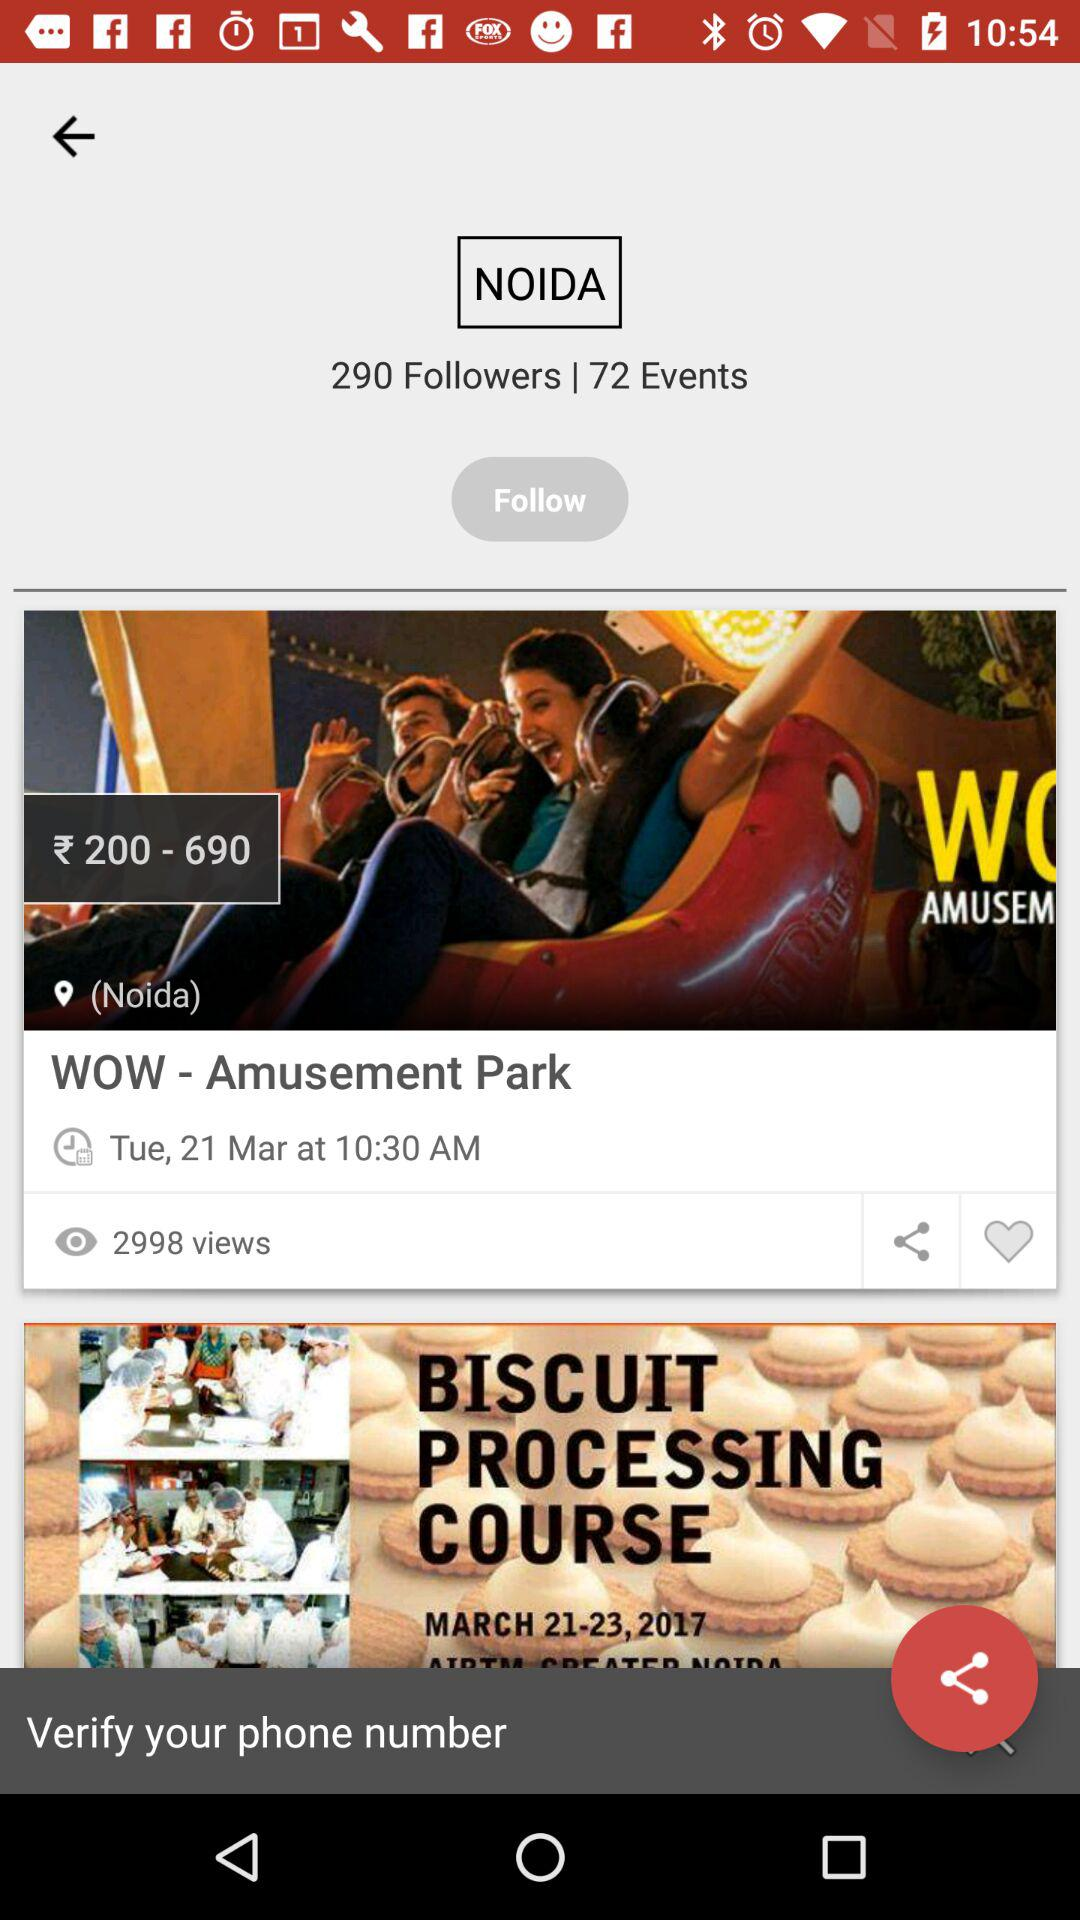How many comments are on "WOW - Amusement Park"?
When the provided information is insufficient, respond with <no answer>. <no answer> 